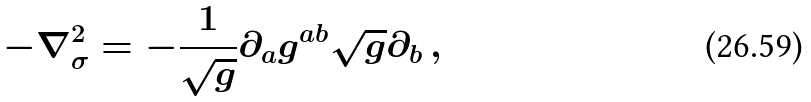Convert formula to latex. <formula><loc_0><loc_0><loc_500><loc_500>- \nabla ^ { 2 } _ { \sigma } = - \frac { 1 } { \sqrt { g } } \partial _ { a } g ^ { a b } \sqrt { g } \partial _ { b } \, ,</formula> 